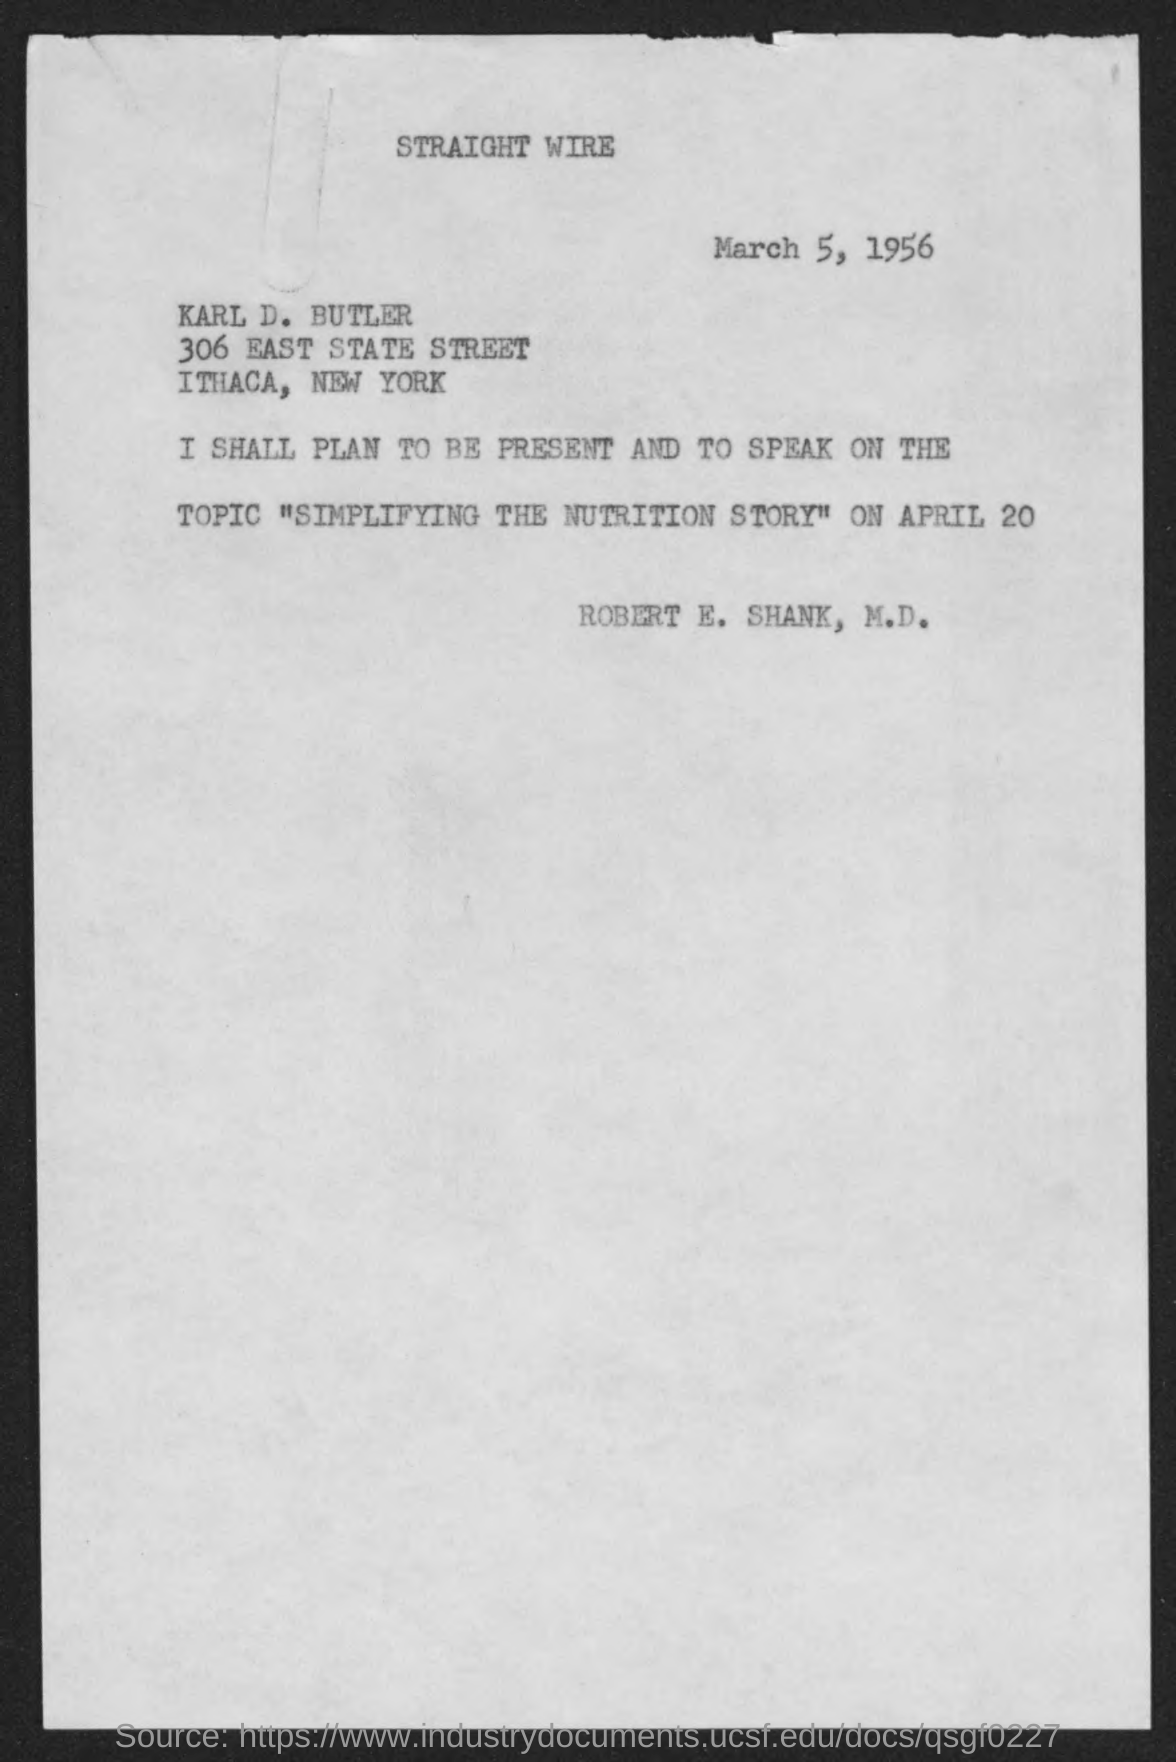Outline some significant characteristics in this image. The date mentioned on the given page is March 5, 1956. On April 20, the individual must present and speak on the assigned topic. The topic name mentioned in the given letter is "Simplifying the Nutrition Story. 